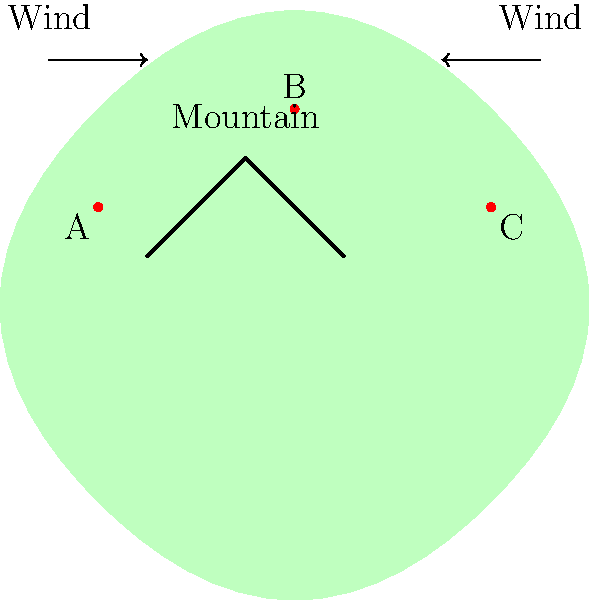Based on the terrain and wind patterns shown in the diagram of Puerto Rico, which of the three proposed wind turbine locations (A, B, or C) would likely be the most optimal for maximum energy production? To determine the most optimal location for a wind turbine, we need to consider several factors:

1. Wind patterns: The diagram shows wind flowing from both sides of the island towards the center.

2. Terrain: There's a mountain in the center of the island, which can affect wind flow.

3. Turbine locations: We have three options - A, B, and C.

Let's analyze each location:

A. Located on the left side of the island, it receives unobstructed wind from the left. However, it might not benefit from wind coming from the right due to the mountain blocking it.

B. Positioned at the top of the mountain. This location can benefit from:
   - Wind speed-up effect: Wind tends to accelerate as it moves over hills and ridges.
   - Access to winds from both directions: Its elevated position allows it to capture winds from both sides of the island.
   - Less surface friction: Higher altitudes generally have less friction, allowing for stronger winds.

C. Similar to A, but on the right side. It receives unobstructed wind from the right but might miss out on wind from the left due to the mountain.

The wind speed at a given height is typically modeled using the power law profile:

$$ v = v_ref \left(\frac{h}{h_{ref}}\right)^α $$

Where:
$v$ is the wind speed at height $h$
$v_ref$ is the reference wind speed at height $h_{ref}$
$α$ is the wind shear exponent (typically around 0.14 for neutral stability conditions)

This equation shows that wind speed increases with height, favoring elevated positions like B.
Answer: B 